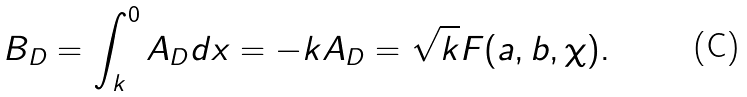Convert formula to latex. <formula><loc_0><loc_0><loc_500><loc_500>B _ { D } = \int _ { k } ^ { 0 } A _ { D } d x = - k A _ { D } = \sqrt { k } F ( a , b , \chi ) .</formula> 